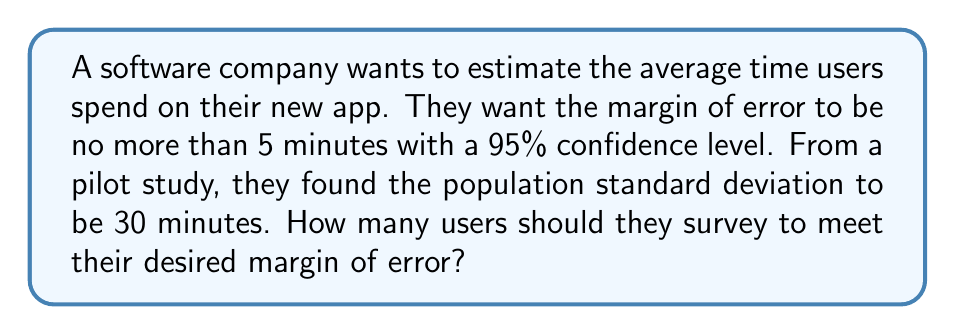Can you solve this math problem? Let's approach this step-by-step:

1. Identify the given information:
   - Desired margin of error (E) = 5 minutes
   - Confidence level = 95%
   - Population standard deviation (σ) = 30 minutes

2. For a 95% confidence level, the z-score (z) is 1.96.

3. The formula for sample size (n) given a specific margin of error is:

   $$n = \left(\frac{z\sigma}{E}\right)^2$$

4. Substitute the known values into the formula:

   $$n = \left(\frac{1.96 \cdot 30}{5}\right)^2$$

5. Simplify:
   $$n = \left(\frac{58.8}{5}\right)^2 = (11.76)^2 = 138.2976$$

6. Since we can't survey a fractional number of users, we round up to the nearest whole number.
Answer: 139 users 